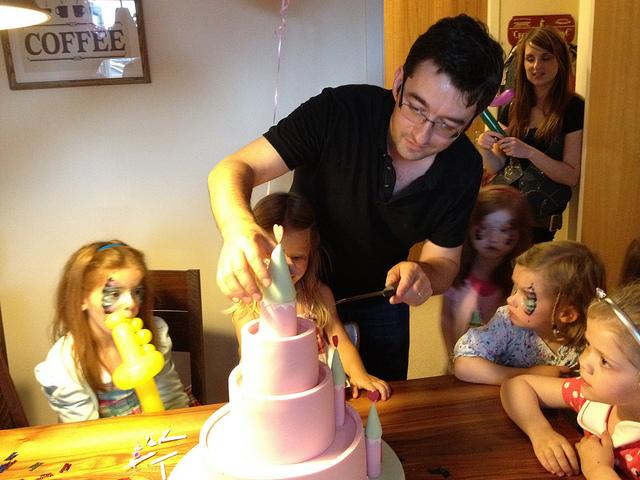Where was the castle themed birthday cake most likely created? bakery 